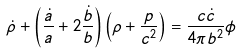<formula> <loc_0><loc_0><loc_500><loc_500>\dot { \rho } + \left ( \frac { \dot { a } } { a } + 2 \frac { \dot { b } } { b } \right ) \left ( \rho + \frac { p } { c ^ { 2 } } \right ) = \frac { c \dot { c } } { 4 \pi b ^ { 2 } } \phi</formula> 